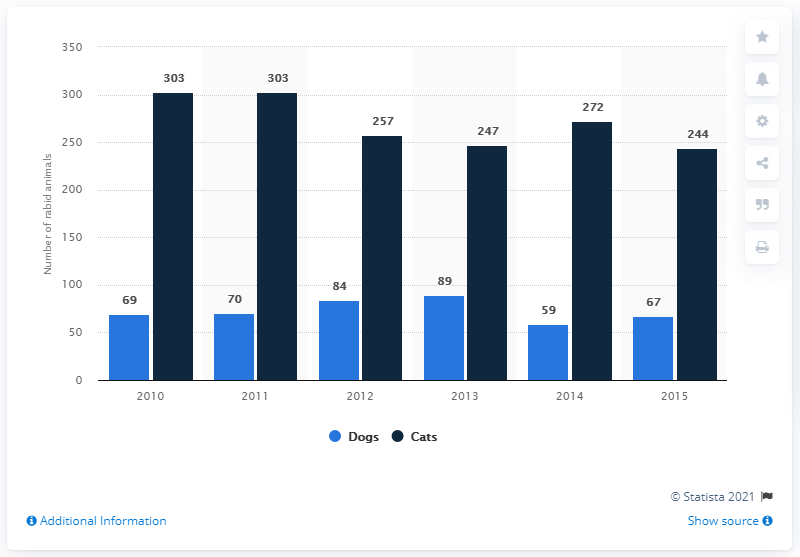Mention a couple of crucial points in this snapshot. In 2015, there were 67 reported cases of rabies in dogs. 